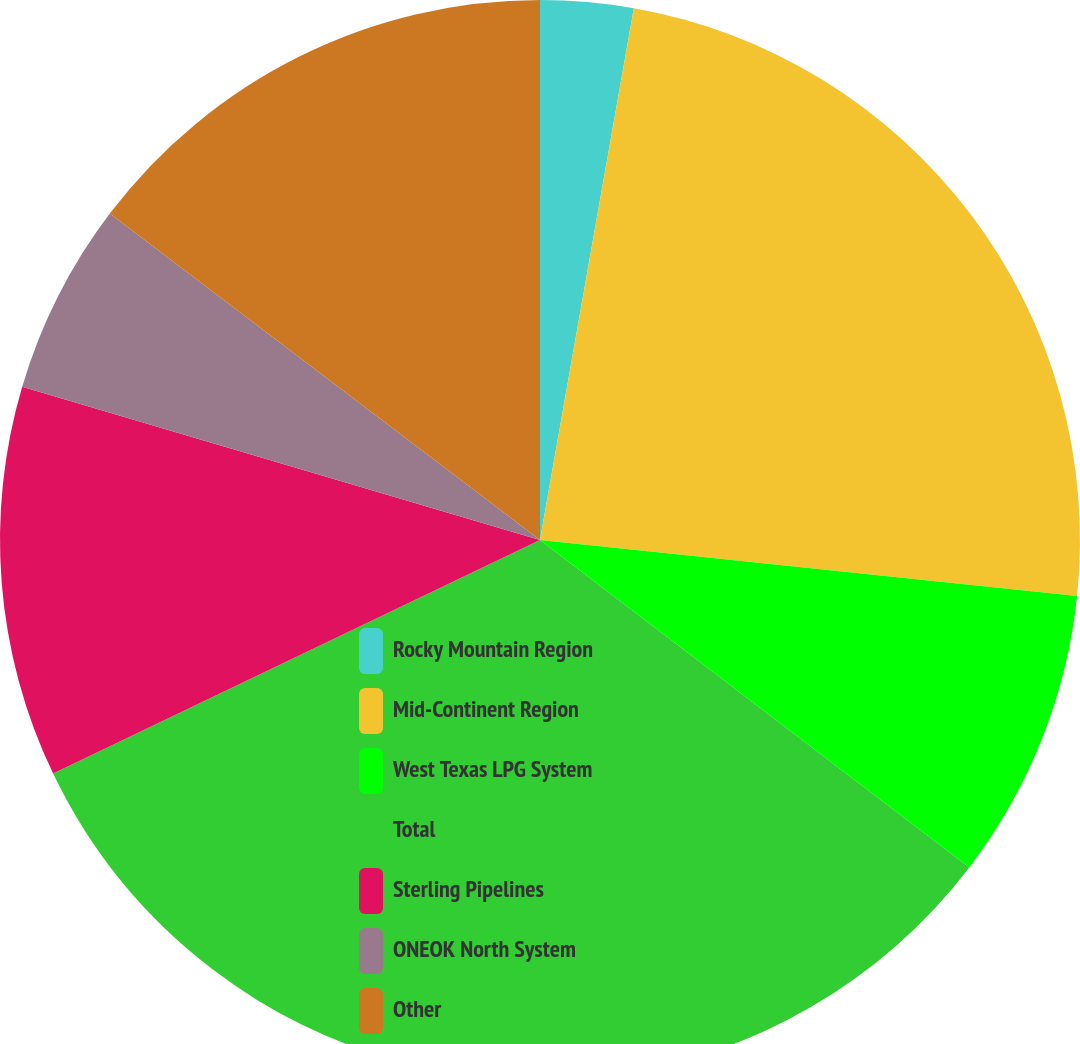Convert chart. <chart><loc_0><loc_0><loc_500><loc_500><pie_chart><fcel>Rocky Mountain Region<fcel>Mid-Continent Region<fcel>West Texas LPG System<fcel>Total<fcel>Sterling Pipelines<fcel>ONEOK North System<fcel>Other<nl><fcel>2.78%<fcel>23.87%<fcel>8.72%<fcel>32.51%<fcel>11.7%<fcel>5.75%<fcel>14.67%<nl></chart> 